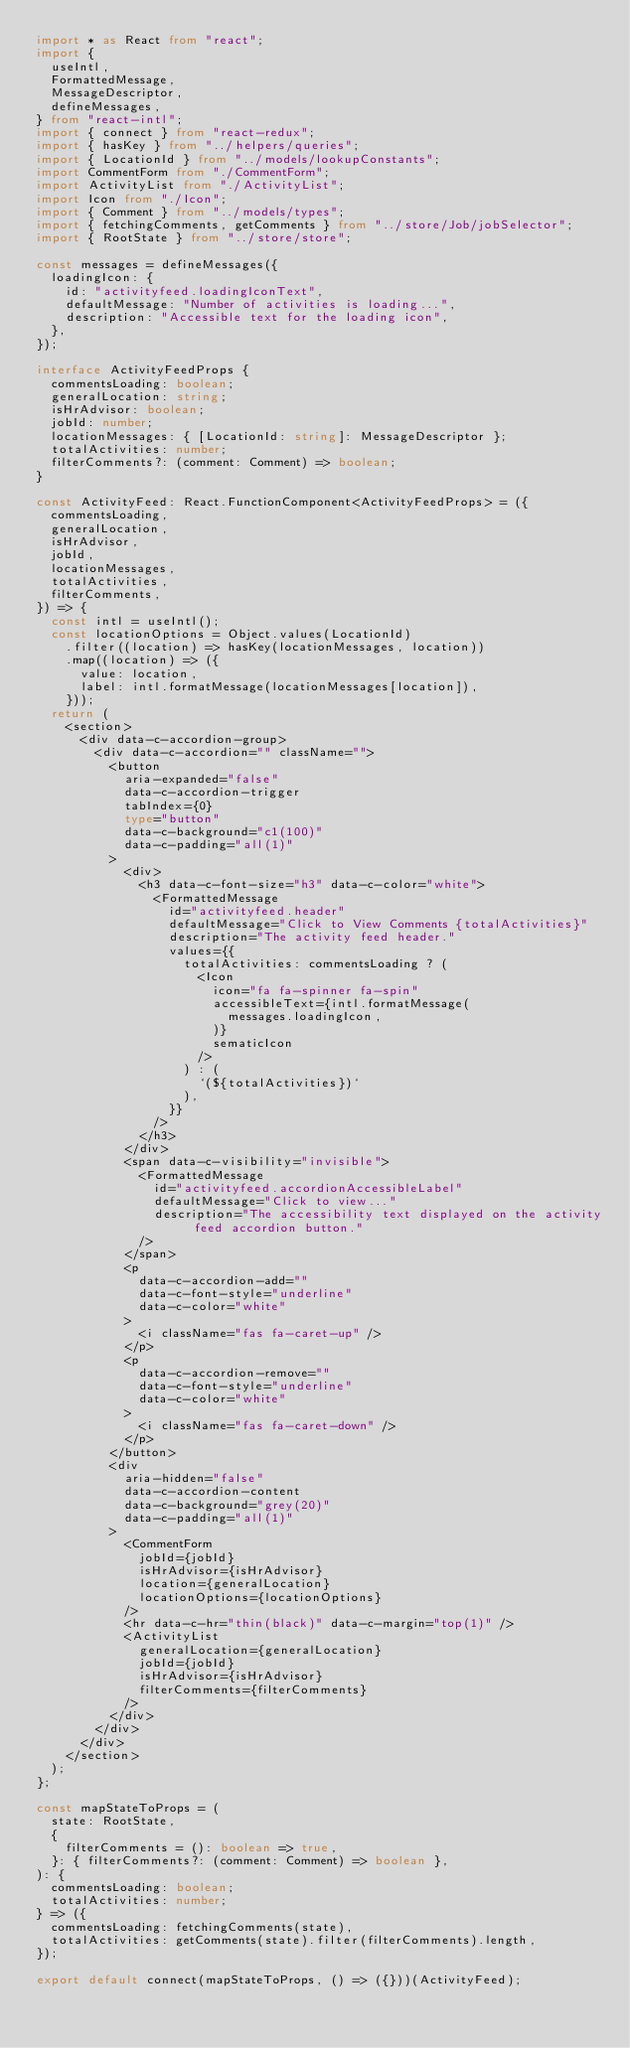Convert code to text. <code><loc_0><loc_0><loc_500><loc_500><_TypeScript_>import * as React from "react";
import {
  useIntl,
  FormattedMessage,
  MessageDescriptor,
  defineMessages,
} from "react-intl";
import { connect } from "react-redux";
import { hasKey } from "../helpers/queries";
import { LocationId } from "../models/lookupConstants";
import CommentForm from "./CommentForm";
import ActivityList from "./ActivityList";
import Icon from "./Icon";
import { Comment } from "../models/types";
import { fetchingComments, getComments } from "../store/Job/jobSelector";
import { RootState } from "../store/store";

const messages = defineMessages({
  loadingIcon: {
    id: "activityfeed.loadingIconText",
    defaultMessage: "Number of activities is loading...",
    description: "Accessible text for the loading icon",
  },
});

interface ActivityFeedProps {
  commentsLoading: boolean;
  generalLocation: string;
  isHrAdvisor: boolean;
  jobId: number;
  locationMessages: { [LocationId: string]: MessageDescriptor };
  totalActivities: number;
  filterComments?: (comment: Comment) => boolean;
}

const ActivityFeed: React.FunctionComponent<ActivityFeedProps> = ({
  commentsLoading,
  generalLocation,
  isHrAdvisor,
  jobId,
  locationMessages,
  totalActivities,
  filterComments,
}) => {
  const intl = useIntl();
  const locationOptions = Object.values(LocationId)
    .filter((location) => hasKey(locationMessages, location))
    .map((location) => ({
      value: location,
      label: intl.formatMessage(locationMessages[location]),
    }));
  return (
    <section>
      <div data-c-accordion-group>
        <div data-c-accordion="" className="">
          <button
            aria-expanded="false"
            data-c-accordion-trigger
            tabIndex={0}
            type="button"
            data-c-background="c1(100)"
            data-c-padding="all(1)"
          >
            <div>
              <h3 data-c-font-size="h3" data-c-color="white">
                <FormattedMessage
                  id="activityfeed.header"
                  defaultMessage="Click to View Comments {totalActivities}"
                  description="The activity feed header."
                  values={{
                    totalActivities: commentsLoading ? (
                      <Icon
                        icon="fa fa-spinner fa-spin"
                        accessibleText={intl.formatMessage(
                          messages.loadingIcon,
                        )}
                        sematicIcon
                      />
                    ) : (
                      `(${totalActivities})`
                    ),
                  }}
                />
              </h3>
            </div>
            <span data-c-visibility="invisible">
              <FormattedMessage
                id="activityfeed.accordionAccessibleLabel"
                defaultMessage="Click to view..."
                description="The accessibility text displayed on the activity feed accordion button."
              />
            </span>
            <p
              data-c-accordion-add=""
              data-c-font-style="underline"
              data-c-color="white"
            >
              <i className="fas fa-caret-up" />
            </p>
            <p
              data-c-accordion-remove=""
              data-c-font-style="underline"
              data-c-color="white"
            >
              <i className="fas fa-caret-down" />
            </p>
          </button>
          <div
            aria-hidden="false"
            data-c-accordion-content
            data-c-background="grey(20)"
            data-c-padding="all(1)"
          >
            <CommentForm
              jobId={jobId}
              isHrAdvisor={isHrAdvisor}
              location={generalLocation}
              locationOptions={locationOptions}
            />
            <hr data-c-hr="thin(black)" data-c-margin="top(1)" />
            <ActivityList
              generalLocation={generalLocation}
              jobId={jobId}
              isHrAdvisor={isHrAdvisor}
              filterComments={filterComments}
            />
          </div>
        </div>
      </div>
    </section>
  );
};

const mapStateToProps = (
  state: RootState,
  {
    filterComments = (): boolean => true,
  }: { filterComments?: (comment: Comment) => boolean },
): {
  commentsLoading: boolean;
  totalActivities: number;
} => ({
  commentsLoading: fetchingComments(state),
  totalActivities: getComments(state).filter(filterComments).length,
});

export default connect(mapStateToProps, () => ({}))(ActivityFeed);
</code> 